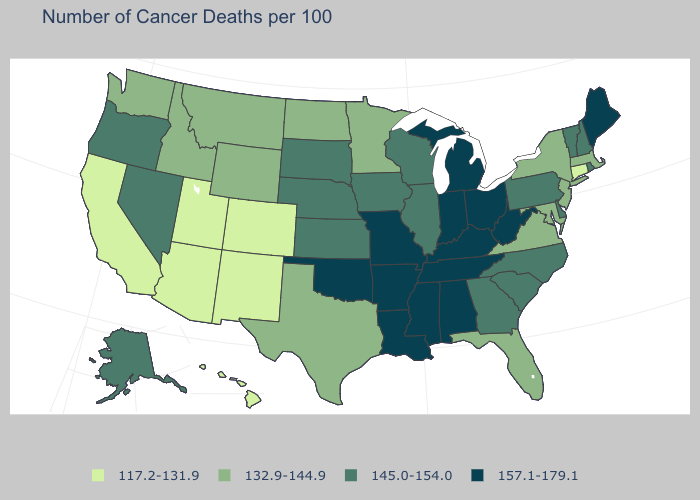What is the lowest value in the USA?
Be succinct. 117.2-131.9. Name the states that have a value in the range 117.2-131.9?
Keep it brief. Arizona, California, Colorado, Connecticut, Hawaii, New Mexico, Utah. Does Alabama have the highest value in the USA?
Answer briefly. Yes. What is the highest value in the MidWest ?
Concise answer only. 157.1-179.1. Does Arizona have the lowest value in the USA?
Write a very short answer. Yes. What is the value of South Carolina?
Be succinct. 145.0-154.0. Does New Mexico have the highest value in the USA?
Answer briefly. No. What is the value of Texas?
Give a very brief answer. 132.9-144.9. What is the highest value in states that border New York?
Answer briefly. 145.0-154.0. Does Connecticut have the lowest value in the Northeast?
Give a very brief answer. Yes. What is the value of Massachusetts?
Answer briefly. 132.9-144.9. Which states hav the highest value in the MidWest?
Keep it brief. Indiana, Michigan, Missouri, Ohio. Does South Dakota have the same value as Kansas?
Answer briefly. Yes. What is the highest value in the USA?
Quick response, please. 157.1-179.1. Does Idaho have a higher value than Utah?
Keep it brief. Yes. 